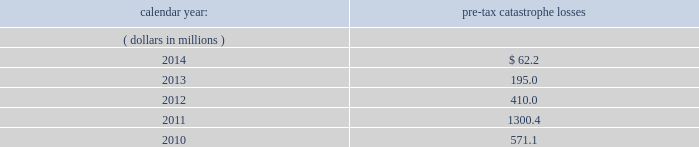Available information .
The company 2019s annual reports on form 10-k , quarterly reports on form 10-q , current reports on form 8- k , proxy statements and amendments to those reports are available free of charge through the company 2019s internet website at http://www.everestregroup.com as soon as reasonably practicable after such reports are electronically filed with the securities and exchange commission ( the 201csec 201d ) .
Item 1a .
Risk factors in addition to the other information provided in this report , the following risk factors should be considered when evaluating an investment in our securities .
If the circumstances contemplated by the individual risk factors materialize , our business , financial condition and results of operations could be materially and adversely affected and the trading price of our common shares could decline significantly .
Risks relating to our business fluctuations in the financial markets could result in investment losses .
Prolonged and severe disruptions in the overall public debt and equity markets , such as occurred during 2008 , could result in significant realized and unrealized losses in our investment portfolio .
Although financial markets have significantly improved since 2008 , they could deteriorate in the future .
There could also be disruption in individual market sectors , such as occurred in the energy sector during the fourth quarter of 2014 .
Such declines in the financial markets could result in significant realized and unrealized losses on investments and could have a material adverse impact on our results of operations , equity , business and insurer financial strength and debt ratings .
Our results could be adversely affected by catastrophic events .
We are exposed to unpredictable catastrophic events , including weather-related and other natural catastrophes , as well as acts of terrorism .
Any material reduction in our operating results caused by the occurrence of one or more catastrophes could inhibit our ability to pay dividends or to meet our interest and principal payment obligations .
Subsequent to april 1 , 2010 , we define a catastrophe as an event that causes a loss on property exposures before reinsurance of at least $ 10.0 million , before corporate level reinsurance and taxes .
Prior to april 1 , 2010 , we used a threshold of $ 5.0 million .
By way of illustration , during the past five calendar years , pre-tax catastrophe losses , net of contract specific reinsurance but before cessions under corporate reinsurance programs , were as follows: .
Our losses from future catastrophic events could exceed our projections .
We use projections of possible losses from future catastrophic events of varying types and magnitudes as a strategic underwriting tool .
We use these loss projections to estimate our potential catastrophe losses in certain geographic areas and decide on the placement of retrocessional coverage or other actions to limit the extent of potential losses in a given geographic area .
These loss projections are approximations , reliant on a mix of quantitative and qualitative processes , and actual losses may exceed the projections by a material amount , resulting in a material adverse effect on our financial condition and results of operations. .
What was the accumulated pre-tax catastrophe losses from 2010 to 2013 in millions? 
Computations: (((571.1 + 1300.4) + 410.0) + 195.0)
Answer: 2476.5. 